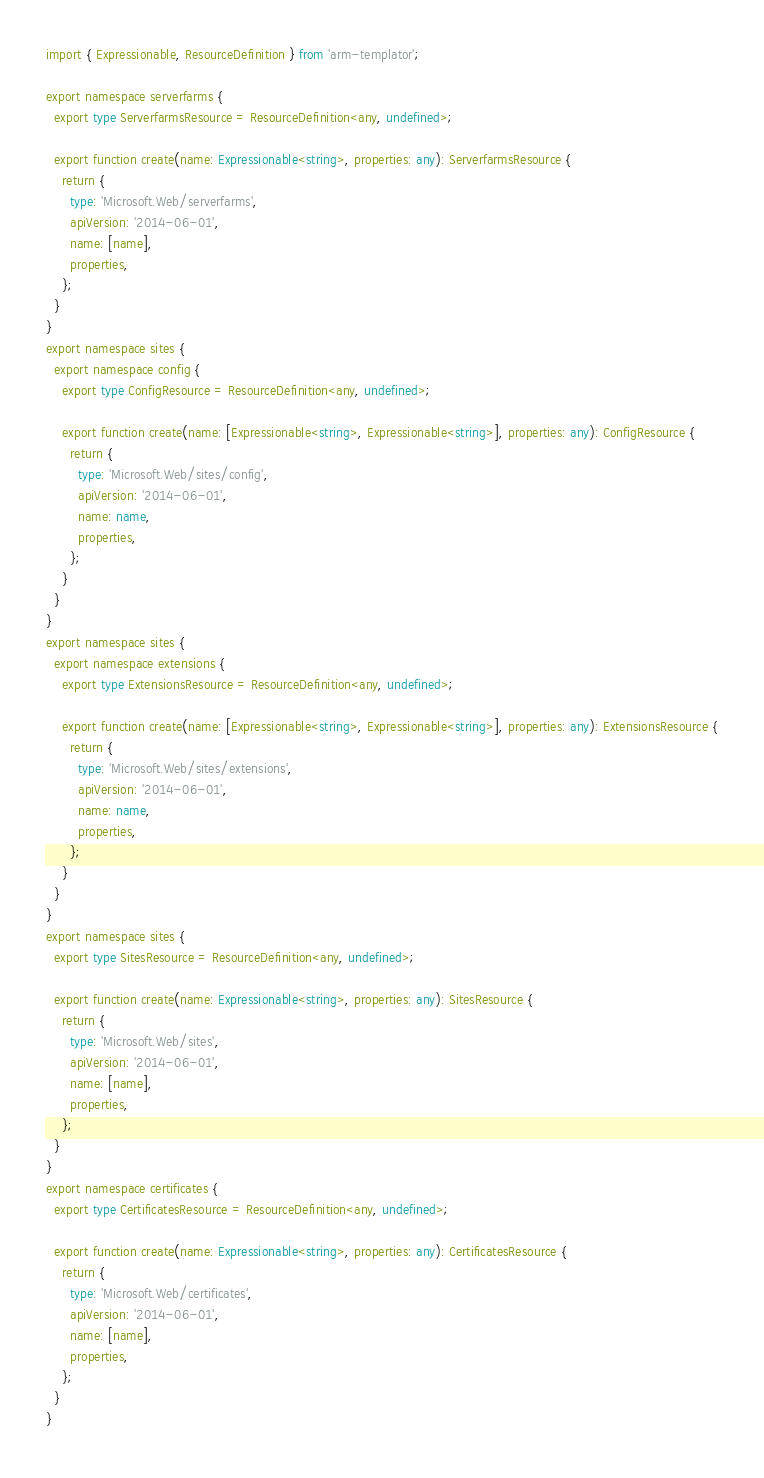Convert code to text. <code><loc_0><loc_0><loc_500><loc_500><_TypeScript_>import { Expressionable, ResourceDefinition } from 'arm-templator';

export namespace serverfarms {
  export type ServerfarmsResource = ResourceDefinition<any, undefined>;
  
  export function create(name: Expressionable<string>, properties: any): ServerfarmsResource {
    return {
      type: 'Microsoft.Web/serverfarms',
      apiVersion: '2014-06-01',
      name: [name],
      properties,
    };
  }
}
export namespace sites {
  export namespace config {
    export type ConfigResource = ResourceDefinition<any, undefined>;
    
    export function create(name: [Expressionable<string>, Expressionable<string>], properties: any): ConfigResource {
      return {
        type: 'Microsoft.Web/sites/config',
        apiVersion: '2014-06-01',
        name: name,
        properties,
      };
    }
  }
}
export namespace sites {
  export namespace extensions {
    export type ExtensionsResource = ResourceDefinition<any, undefined>;
    
    export function create(name: [Expressionable<string>, Expressionable<string>], properties: any): ExtensionsResource {
      return {
        type: 'Microsoft.Web/sites/extensions',
        apiVersion: '2014-06-01',
        name: name,
        properties,
      };
    }
  }
}
export namespace sites {
  export type SitesResource = ResourceDefinition<any, undefined>;
  
  export function create(name: Expressionable<string>, properties: any): SitesResource {
    return {
      type: 'Microsoft.Web/sites',
      apiVersion: '2014-06-01',
      name: [name],
      properties,
    };
  }
}
export namespace certificates {
  export type CertificatesResource = ResourceDefinition<any, undefined>;
  
  export function create(name: Expressionable<string>, properties: any): CertificatesResource {
    return {
      type: 'Microsoft.Web/certificates',
      apiVersion: '2014-06-01',
      name: [name],
      properties,
    };
  }
}</code> 